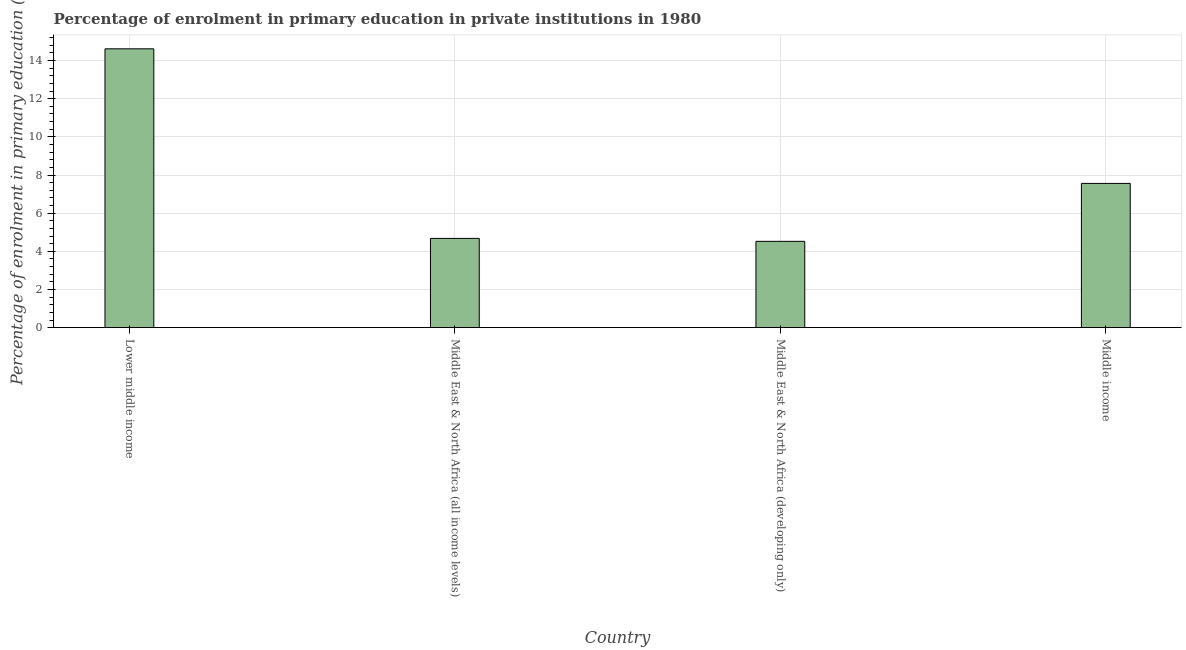What is the title of the graph?
Provide a short and direct response. Percentage of enrolment in primary education in private institutions in 1980. What is the label or title of the X-axis?
Make the answer very short. Country. What is the label or title of the Y-axis?
Ensure brevity in your answer.  Percentage of enrolment in primary education (%). What is the enrolment percentage in primary education in Middle East & North Africa (developing only)?
Keep it short and to the point. 4.53. Across all countries, what is the maximum enrolment percentage in primary education?
Offer a terse response. 14.62. Across all countries, what is the minimum enrolment percentage in primary education?
Your answer should be compact. 4.53. In which country was the enrolment percentage in primary education maximum?
Give a very brief answer. Lower middle income. In which country was the enrolment percentage in primary education minimum?
Your response must be concise. Middle East & North Africa (developing only). What is the sum of the enrolment percentage in primary education?
Your response must be concise. 31.38. What is the difference between the enrolment percentage in primary education in Lower middle income and Middle East & North Africa (all income levels)?
Your answer should be very brief. 9.94. What is the average enrolment percentage in primary education per country?
Your answer should be compact. 7.84. What is the median enrolment percentage in primary education?
Provide a short and direct response. 6.12. In how many countries, is the enrolment percentage in primary education greater than 12.4 %?
Keep it short and to the point. 1. What is the ratio of the enrolment percentage in primary education in Lower middle income to that in Middle income?
Ensure brevity in your answer.  1.93. Is the difference between the enrolment percentage in primary education in Middle East & North Africa (developing only) and Middle income greater than the difference between any two countries?
Your response must be concise. No. What is the difference between the highest and the second highest enrolment percentage in primary education?
Keep it short and to the point. 7.05. Is the sum of the enrolment percentage in primary education in Lower middle income and Middle East & North Africa (developing only) greater than the maximum enrolment percentage in primary education across all countries?
Provide a succinct answer. Yes. What is the difference between the highest and the lowest enrolment percentage in primary education?
Make the answer very short. 10.09. How many bars are there?
Offer a very short reply. 4. Are all the bars in the graph horizontal?
Your response must be concise. No. Are the values on the major ticks of Y-axis written in scientific E-notation?
Provide a succinct answer. No. What is the Percentage of enrolment in primary education (%) in Lower middle income?
Ensure brevity in your answer.  14.62. What is the Percentage of enrolment in primary education (%) of Middle East & North Africa (all income levels)?
Provide a short and direct response. 4.68. What is the Percentage of enrolment in primary education (%) in Middle East & North Africa (developing only)?
Provide a succinct answer. 4.53. What is the Percentage of enrolment in primary education (%) in Middle income?
Ensure brevity in your answer.  7.56. What is the difference between the Percentage of enrolment in primary education (%) in Lower middle income and Middle East & North Africa (all income levels)?
Ensure brevity in your answer.  9.94. What is the difference between the Percentage of enrolment in primary education (%) in Lower middle income and Middle East & North Africa (developing only)?
Your response must be concise. 10.09. What is the difference between the Percentage of enrolment in primary education (%) in Lower middle income and Middle income?
Provide a succinct answer. 7.06. What is the difference between the Percentage of enrolment in primary education (%) in Middle East & North Africa (all income levels) and Middle East & North Africa (developing only)?
Ensure brevity in your answer.  0.15. What is the difference between the Percentage of enrolment in primary education (%) in Middle East & North Africa (all income levels) and Middle income?
Your response must be concise. -2.88. What is the difference between the Percentage of enrolment in primary education (%) in Middle East & North Africa (developing only) and Middle income?
Offer a terse response. -3.04. What is the ratio of the Percentage of enrolment in primary education (%) in Lower middle income to that in Middle East & North Africa (all income levels)?
Give a very brief answer. 3.12. What is the ratio of the Percentage of enrolment in primary education (%) in Lower middle income to that in Middle East & North Africa (developing only)?
Your response must be concise. 3.23. What is the ratio of the Percentage of enrolment in primary education (%) in Lower middle income to that in Middle income?
Offer a terse response. 1.93. What is the ratio of the Percentage of enrolment in primary education (%) in Middle East & North Africa (all income levels) to that in Middle East & North Africa (developing only)?
Offer a very short reply. 1.03. What is the ratio of the Percentage of enrolment in primary education (%) in Middle East & North Africa (all income levels) to that in Middle income?
Keep it short and to the point. 0.62. What is the ratio of the Percentage of enrolment in primary education (%) in Middle East & North Africa (developing only) to that in Middle income?
Give a very brief answer. 0.6. 